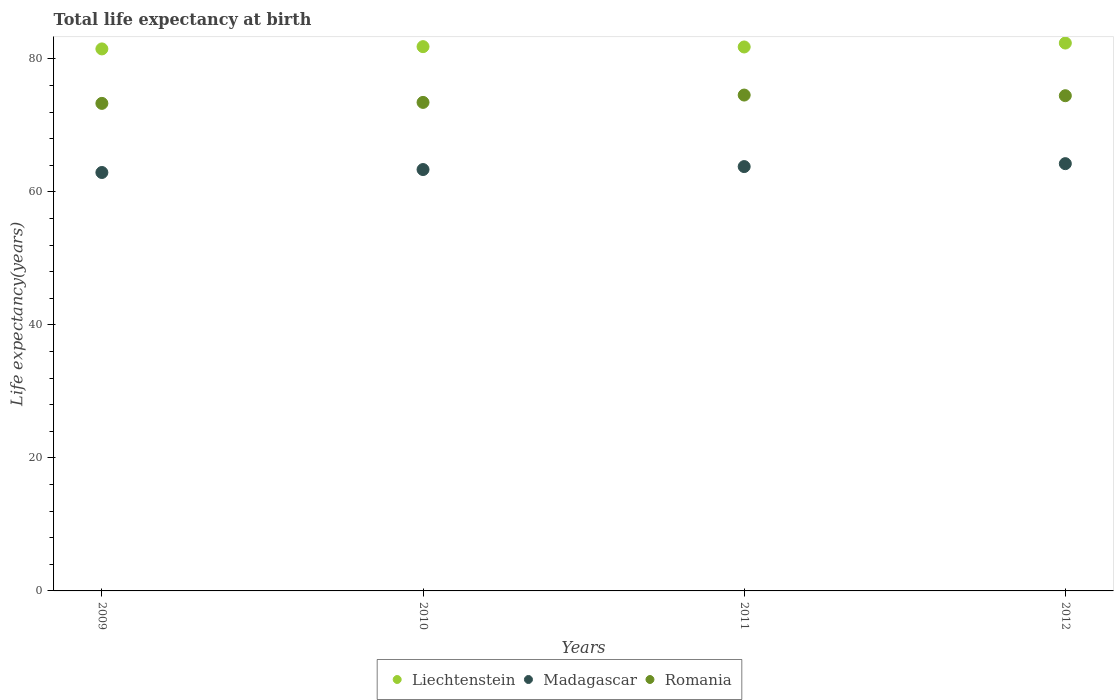How many different coloured dotlines are there?
Provide a short and direct response. 3. What is the life expectancy at birth in in Liechtenstein in 2010?
Make the answer very short. 81.84. Across all years, what is the maximum life expectancy at birth in in Romania?
Offer a very short reply. 74.56. Across all years, what is the minimum life expectancy at birth in in Liechtenstein?
Offer a terse response. 81.5. What is the total life expectancy at birth in in Romania in the graph?
Offer a very short reply. 295.8. What is the difference between the life expectancy at birth in in Liechtenstein in 2010 and that in 2011?
Your answer should be compact. 0.05. What is the difference between the life expectancy at birth in in Madagascar in 2011 and the life expectancy at birth in in Romania in 2010?
Your answer should be compact. -9.65. What is the average life expectancy at birth in in Madagascar per year?
Provide a succinct answer. 63.58. In the year 2012, what is the difference between the life expectancy at birth in in Madagascar and life expectancy at birth in in Liechtenstein?
Keep it short and to the point. -18.14. In how many years, is the life expectancy at birth in in Liechtenstein greater than 16 years?
Your response must be concise. 4. What is the ratio of the life expectancy at birth in in Liechtenstein in 2009 to that in 2010?
Your answer should be very brief. 1. Is the difference between the life expectancy at birth in in Madagascar in 2010 and 2012 greater than the difference between the life expectancy at birth in in Liechtenstein in 2010 and 2012?
Provide a succinct answer. No. What is the difference between the highest and the second highest life expectancy at birth in in Romania?
Your answer should be very brief. 0.1. What is the difference between the highest and the lowest life expectancy at birth in in Madagascar?
Give a very brief answer. 1.33. Is the life expectancy at birth in in Romania strictly greater than the life expectancy at birth in in Madagascar over the years?
Offer a very short reply. Yes. Does the graph contain any zero values?
Provide a short and direct response. No. Does the graph contain grids?
Keep it short and to the point. No. What is the title of the graph?
Give a very brief answer. Total life expectancy at birth. Does "Kuwait" appear as one of the legend labels in the graph?
Provide a short and direct response. No. What is the label or title of the X-axis?
Your response must be concise. Years. What is the label or title of the Y-axis?
Make the answer very short. Life expectancy(years). What is the Life expectancy(years) in Liechtenstein in 2009?
Your answer should be compact. 81.5. What is the Life expectancy(years) of Madagascar in 2009?
Keep it short and to the point. 62.92. What is the Life expectancy(years) in Romania in 2009?
Keep it short and to the point. 73.31. What is the Life expectancy(years) of Liechtenstein in 2010?
Make the answer very short. 81.84. What is the Life expectancy(years) in Madagascar in 2010?
Your answer should be very brief. 63.36. What is the Life expectancy(years) of Romania in 2010?
Keep it short and to the point. 73.46. What is the Life expectancy(years) of Liechtenstein in 2011?
Make the answer very short. 81.79. What is the Life expectancy(years) in Madagascar in 2011?
Provide a short and direct response. 63.81. What is the Life expectancy(years) of Romania in 2011?
Provide a succinct answer. 74.56. What is the Life expectancy(years) of Liechtenstein in 2012?
Offer a very short reply. 82.38. What is the Life expectancy(years) in Madagascar in 2012?
Provide a short and direct response. 64.25. What is the Life expectancy(years) in Romania in 2012?
Your answer should be very brief. 74.46. Across all years, what is the maximum Life expectancy(years) of Liechtenstein?
Keep it short and to the point. 82.38. Across all years, what is the maximum Life expectancy(years) in Madagascar?
Your answer should be very brief. 64.25. Across all years, what is the maximum Life expectancy(years) in Romania?
Your answer should be compact. 74.56. Across all years, what is the minimum Life expectancy(years) in Liechtenstein?
Your answer should be very brief. 81.5. Across all years, what is the minimum Life expectancy(years) of Madagascar?
Provide a succinct answer. 62.92. Across all years, what is the minimum Life expectancy(years) of Romania?
Give a very brief answer. 73.31. What is the total Life expectancy(years) of Liechtenstein in the graph?
Offer a very short reply. 327.52. What is the total Life expectancy(years) in Madagascar in the graph?
Offer a very short reply. 254.33. What is the total Life expectancy(years) in Romania in the graph?
Your answer should be very brief. 295.8. What is the difference between the Life expectancy(years) of Liechtenstein in 2009 and that in 2010?
Ensure brevity in your answer.  -0.34. What is the difference between the Life expectancy(years) in Madagascar in 2009 and that in 2010?
Your answer should be very brief. -0.44. What is the difference between the Life expectancy(years) of Romania in 2009 and that in 2010?
Your answer should be compact. -0.15. What is the difference between the Life expectancy(years) of Liechtenstein in 2009 and that in 2011?
Provide a succinct answer. -0.29. What is the difference between the Life expectancy(years) of Madagascar in 2009 and that in 2011?
Keep it short and to the point. -0.89. What is the difference between the Life expectancy(years) of Romania in 2009 and that in 2011?
Ensure brevity in your answer.  -1.25. What is the difference between the Life expectancy(years) in Liechtenstein in 2009 and that in 2012?
Offer a very short reply. -0.88. What is the difference between the Life expectancy(years) of Madagascar in 2009 and that in 2012?
Make the answer very short. -1.33. What is the difference between the Life expectancy(years) in Romania in 2009 and that in 2012?
Make the answer very short. -1.15. What is the difference between the Life expectancy(years) in Liechtenstein in 2010 and that in 2011?
Offer a terse response. 0.05. What is the difference between the Life expectancy(years) of Madagascar in 2010 and that in 2011?
Make the answer very short. -0.45. What is the difference between the Life expectancy(years) in Romania in 2010 and that in 2011?
Your answer should be very brief. -1.1. What is the difference between the Life expectancy(years) in Liechtenstein in 2010 and that in 2012?
Keep it short and to the point. -0.54. What is the difference between the Life expectancy(years) of Madagascar in 2010 and that in 2012?
Provide a succinct answer. -0.88. What is the difference between the Life expectancy(years) in Romania in 2010 and that in 2012?
Your answer should be compact. -1. What is the difference between the Life expectancy(years) of Liechtenstein in 2011 and that in 2012?
Give a very brief answer. -0.59. What is the difference between the Life expectancy(years) of Madagascar in 2011 and that in 2012?
Provide a succinct answer. -0.44. What is the difference between the Life expectancy(years) in Romania in 2011 and that in 2012?
Provide a succinct answer. 0.1. What is the difference between the Life expectancy(years) in Liechtenstein in 2009 and the Life expectancy(years) in Madagascar in 2010?
Ensure brevity in your answer.  18.14. What is the difference between the Life expectancy(years) of Liechtenstein in 2009 and the Life expectancy(years) of Romania in 2010?
Offer a terse response. 8.04. What is the difference between the Life expectancy(years) of Madagascar in 2009 and the Life expectancy(years) of Romania in 2010?
Ensure brevity in your answer.  -10.54. What is the difference between the Life expectancy(years) of Liechtenstein in 2009 and the Life expectancy(years) of Madagascar in 2011?
Provide a short and direct response. 17.69. What is the difference between the Life expectancy(years) of Liechtenstein in 2009 and the Life expectancy(years) of Romania in 2011?
Give a very brief answer. 6.94. What is the difference between the Life expectancy(years) of Madagascar in 2009 and the Life expectancy(years) of Romania in 2011?
Your response must be concise. -11.65. What is the difference between the Life expectancy(years) of Liechtenstein in 2009 and the Life expectancy(years) of Madagascar in 2012?
Make the answer very short. 17.25. What is the difference between the Life expectancy(years) of Liechtenstein in 2009 and the Life expectancy(years) of Romania in 2012?
Keep it short and to the point. 7.04. What is the difference between the Life expectancy(years) of Madagascar in 2009 and the Life expectancy(years) of Romania in 2012?
Offer a very short reply. -11.55. What is the difference between the Life expectancy(years) in Liechtenstein in 2010 and the Life expectancy(years) in Madagascar in 2011?
Your response must be concise. 18.03. What is the difference between the Life expectancy(years) in Liechtenstein in 2010 and the Life expectancy(years) in Romania in 2011?
Provide a succinct answer. 7.28. What is the difference between the Life expectancy(years) of Madagascar in 2010 and the Life expectancy(years) of Romania in 2011?
Make the answer very short. -11.2. What is the difference between the Life expectancy(years) in Liechtenstein in 2010 and the Life expectancy(years) in Madagascar in 2012?
Offer a terse response. 17.59. What is the difference between the Life expectancy(years) in Liechtenstein in 2010 and the Life expectancy(years) in Romania in 2012?
Your response must be concise. 7.38. What is the difference between the Life expectancy(years) in Madagascar in 2010 and the Life expectancy(years) in Romania in 2012?
Offer a terse response. -11.1. What is the difference between the Life expectancy(years) in Liechtenstein in 2011 and the Life expectancy(years) in Madagascar in 2012?
Your answer should be compact. 17.55. What is the difference between the Life expectancy(years) of Liechtenstein in 2011 and the Life expectancy(years) of Romania in 2012?
Keep it short and to the point. 7.33. What is the difference between the Life expectancy(years) in Madagascar in 2011 and the Life expectancy(years) in Romania in 2012?
Keep it short and to the point. -10.66. What is the average Life expectancy(years) in Liechtenstein per year?
Your answer should be very brief. 81.88. What is the average Life expectancy(years) of Madagascar per year?
Offer a very short reply. 63.58. What is the average Life expectancy(years) in Romania per year?
Your answer should be very brief. 73.95. In the year 2009, what is the difference between the Life expectancy(years) in Liechtenstein and Life expectancy(years) in Madagascar?
Offer a very short reply. 18.58. In the year 2009, what is the difference between the Life expectancy(years) of Liechtenstein and Life expectancy(years) of Romania?
Offer a terse response. 8.19. In the year 2009, what is the difference between the Life expectancy(years) of Madagascar and Life expectancy(years) of Romania?
Provide a succinct answer. -10.39. In the year 2010, what is the difference between the Life expectancy(years) of Liechtenstein and Life expectancy(years) of Madagascar?
Your answer should be compact. 18.48. In the year 2010, what is the difference between the Life expectancy(years) in Liechtenstein and Life expectancy(years) in Romania?
Provide a short and direct response. 8.38. In the year 2010, what is the difference between the Life expectancy(years) of Madagascar and Life expectancy(years) of Romania?
Offer a very short reply. -10.1. In the year 2011, what is the difference between the Life expectancy(years) of Liechtenstein and Life expectancy(years) of Madagascar?
Provide a succinct answer. 17.99. In the year 2011, what is the difference between the Life expectancy(years) of Liechtenstein and Life expectancy(years) of Romania?
Keep it short and to the point. 7.23. In the year 2011, what is the difference between the Life expectancy(years) in Madagascar and Life expectancy(years) in Romania?
Ensure brevity in your answer.  -10.76. In the year 2012, what is the difference between the Life expectancy(years) in Liechtenstein and Life expectancy(years) in Madagascar?
Offer a very short reply. 18.14. In the year 2012, what is the difference between the Life expectancy(years) in Liechtenstein and Life expectancy(years) in Romania?
Offer a terse response. 7.92. In the year 2012, what is the difference between the Life expectancy(years) in Madagascar and Life expectancy(years) in Romania?
Your response must be concise. -10.22. What is the ratio of the Life expectancy(years) in Madagascar in 2009 to that in 2010?
Offer a terse response. 0.99. What is the ratio of the Life expectancy(years) of Madagascar in 2009 to that in 2011?
Your answer should be compact. 0.99. What is the ratio of the Life expectancy(years) of Romania in 2009 to that in 2011?
Make the answer very short. 0.98. What is the ratio of the Life expectancy(years) of Liechtenstein in 2009 to that in 2012?
Ensure brevity in your answer.  0.99. What is the ratio of the Life expectancy(years) of Madagascar in 2009 to that in 2012?
Offer a terse response. 0.98. What is the ratio of the Life expectancy(years) in Romania in 2009 to that in 2012?
Keep it short and to the point. 0.98. What is the ratio of the Life expectancy(years) in Liechtenstein in 2010 to that in 2011?
Keep it short and to the point. 1. What is the ratio of the Life expectancy(years) in Madagascar in 2010 to that in 2011?
Offer a very short reply. 0.99. What is the ratio of the Life expectancy(years) in Romania in 2010 to that in 2011?
Give a very brief answer. 0.99. What is the ratio of the Life expectancy(years) in Liechtenstein in 2010 to that in 2012?
Your response must be concise. 0.99. What is the ratio of the Life expectancy(years) of Madagascar in 2010 to that in 2012?
Provide a short and direct response. 0.99. What is the ratio of the Life expectancy(years) of Romania in 2010 to that in 2012?
Offer a very short reply. 0.99. What is the ratio of the Life expectancy(years) of Liechtenstein in 2011 to that in 2012?
Keep it short and to the point. 0.99. What is the ratio of the Life expectancy(years) of Romania in 2011 to that in 2012?
Provide a succinct answer. 1. What is the difference between the highest and the second highest Life expectancy(years) in Liechtenstein?
Give a very brief answer. 0.54. What is the difference between the highest and the second highest Life expectancy(years) of Madagascar?
Ensure brevity in your answer.  0.44. What is the difference between the highest and the lowest Life expectancy(years) in Liechtenstein?
Keep it short and to the point. 0.88. What is the difference between the highest and the lowest Life expectancy(years) of Madagascar?
Offer a very short reply. 1.33. What is the difference between the highest and the lowest Life expectancy(years) in Romania?
Keep it short and to the point. 1.25. 